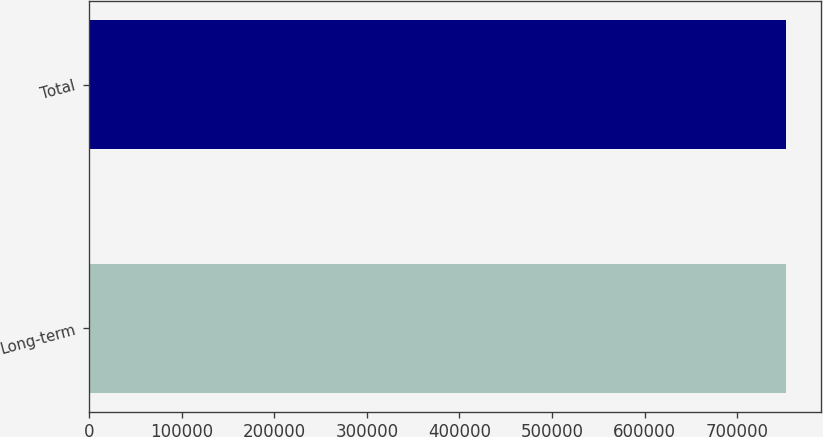<chart> <loc_0><loc_0><loc_500><loc_500><bar_chart><fcel>Long-term<fcel>Total<nl><fcel>752707<fcel>752707<nl></chart> 